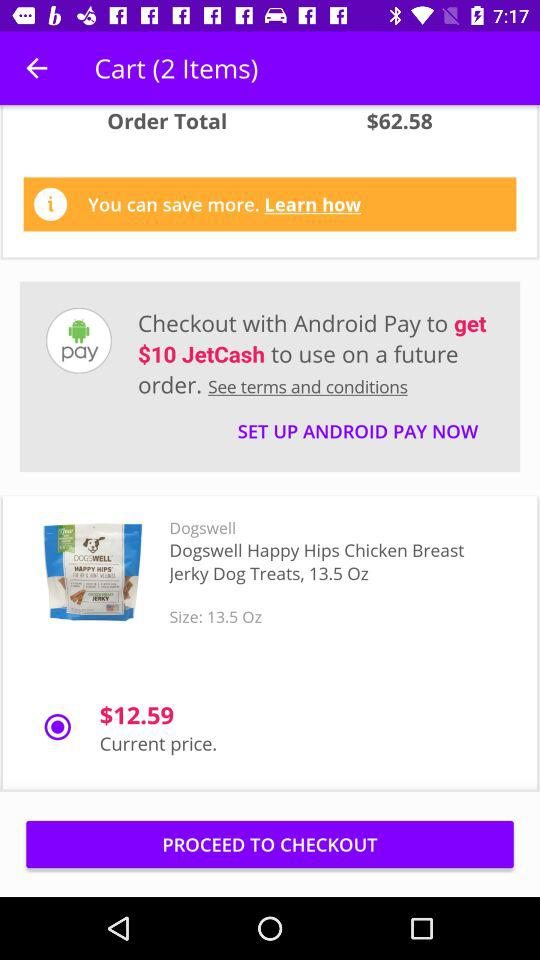What is the order total? The order total is $62.58. 